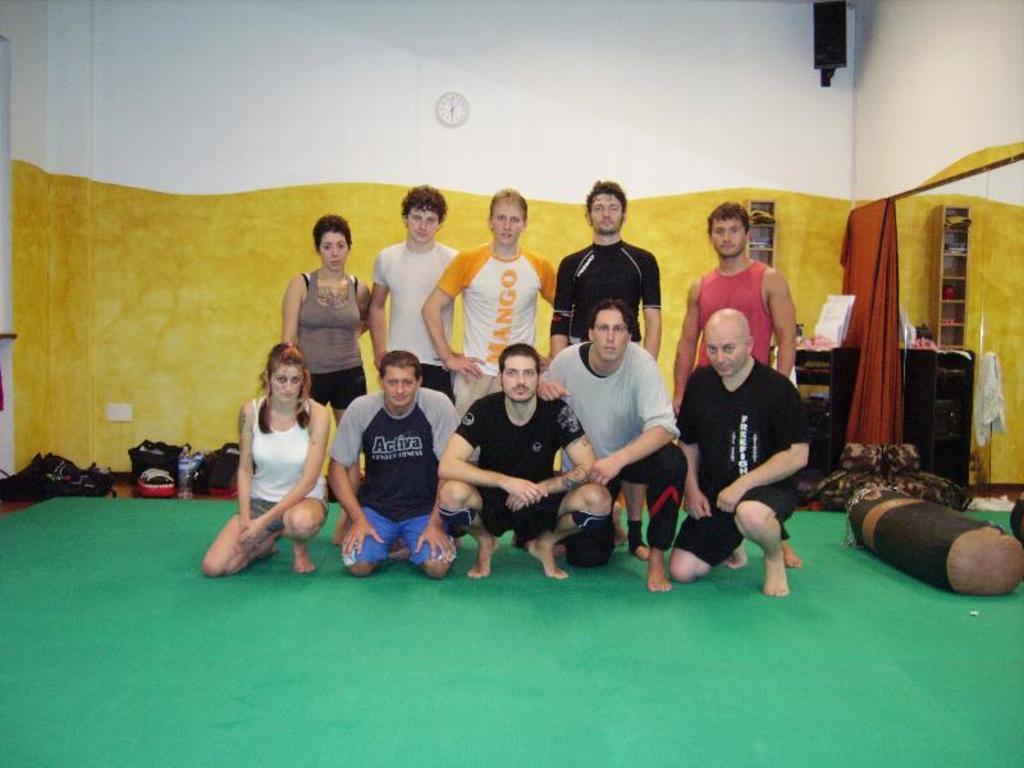How would you summarize this image in a sentence or two? In this image at the center there are few people standing on the mat. Beside them there are pillows. Behind them there are bags. At the right side of the image there are curtains. We can see a table and on top of it there are few objects. At the back side there is a wall with the wall clock on it. At the bottom of the image there is a mat. 